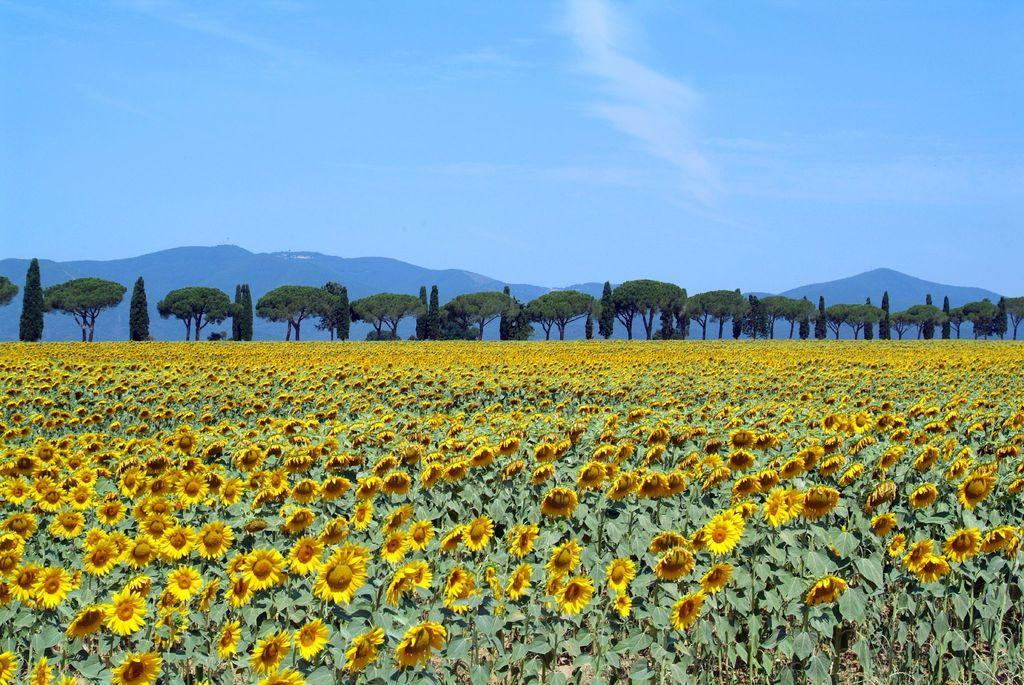What type of flowers can be seen on the plant in the image? There are yellow color flowers on a plant in the image. What can be seen in the background of the image? There are many trees and mountains in the background of the image. What is visible in the sky in the image? The sky is visible in the background of the image. What type of suit is the mountain wearing in the image? There is no suit present in the image, as mountains are inanimate objects and cannot wear clothing. 